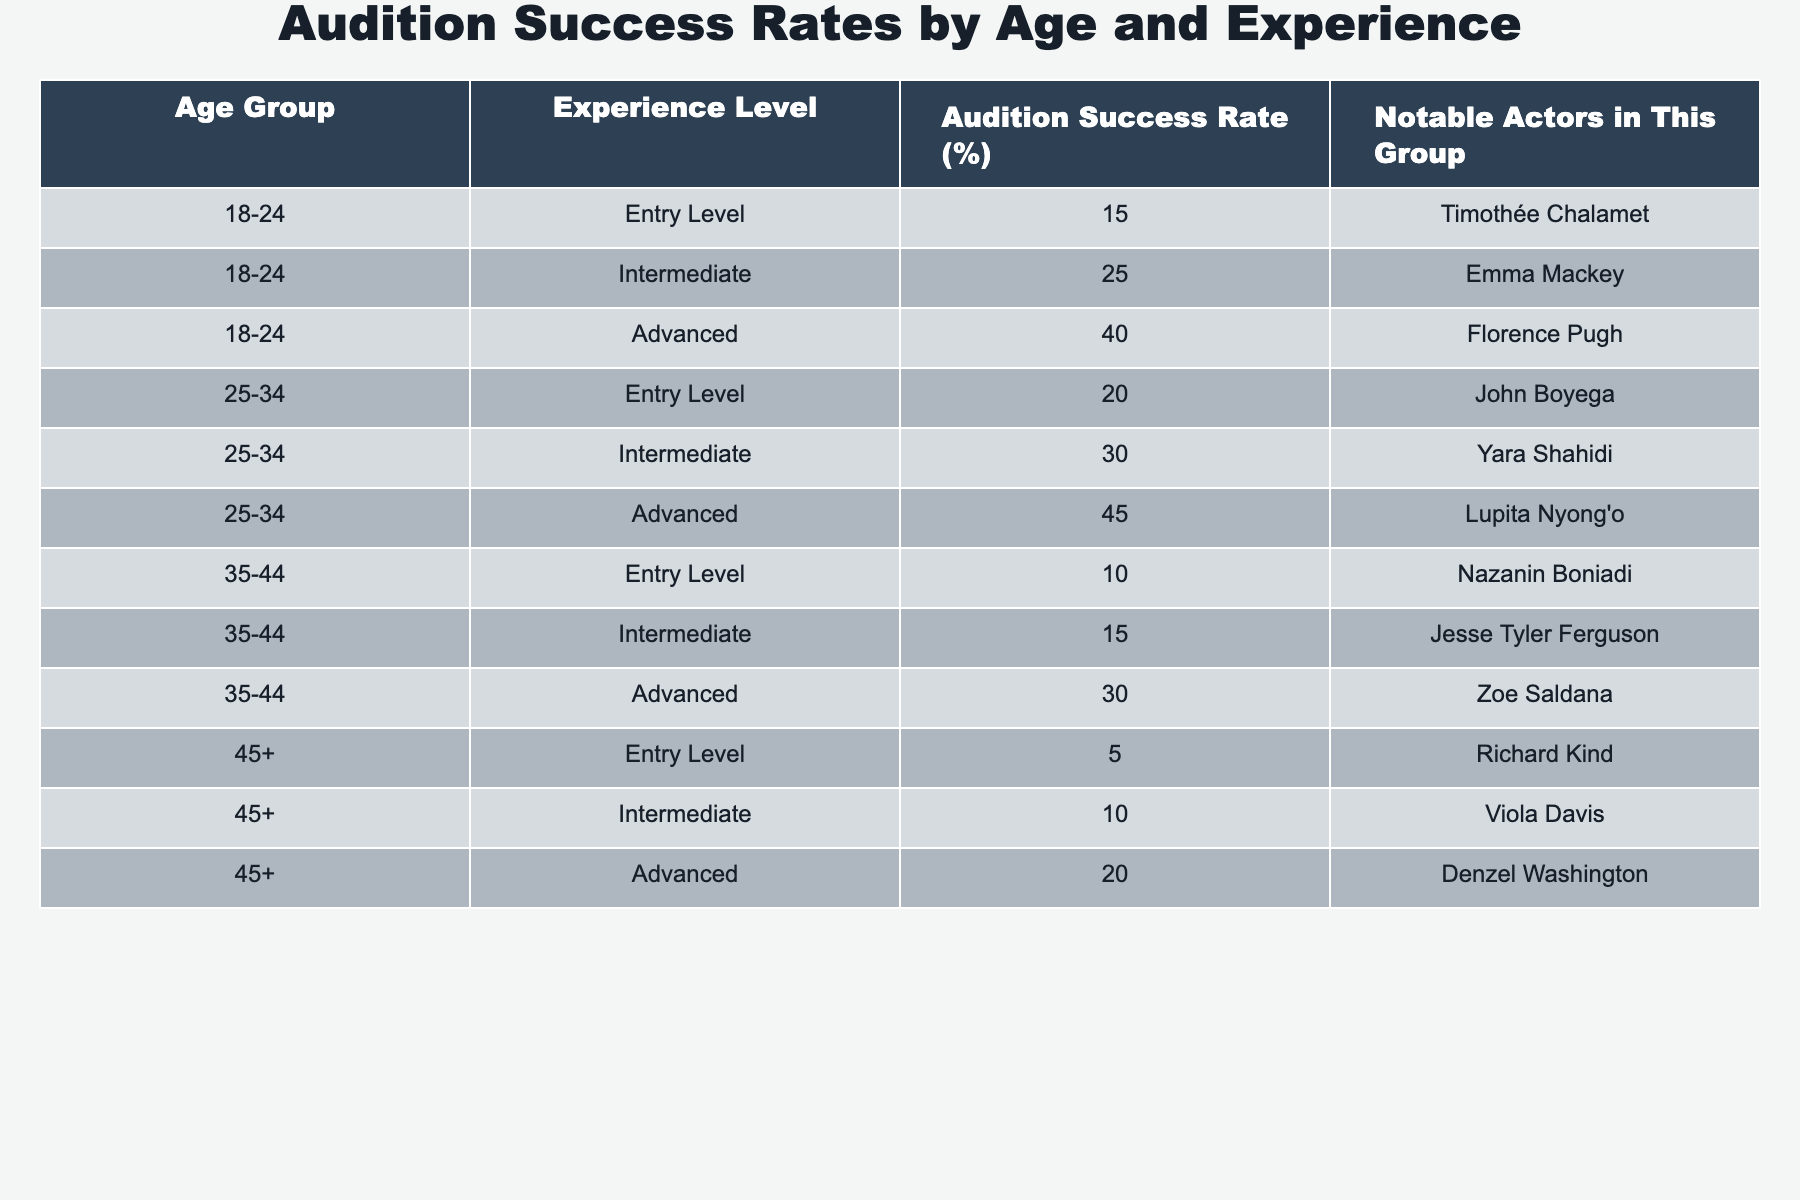What is the audition success rate for actors aged 45 and above at the entry level? From the table, the audition success rate for the "Entry Level" experience among the age group "45+" is listed as 5%.
Answer: 5% Who is the notable actor in the 25-34 age group with the highest success rate? The table shows that the "Advanced" experience level in the 25-34 age group has the highest success rate of 45%, and the notable actor for this group is Lupita Nyong'o.
Answer: Lupita Nyong'o What is the difference in audition success rates between the 18-24 age group advanced level and the 35-44 age group advanced level? The "Advanced" success rate for the 18-24 age group is 40%, while for the 35-44 age group, it's 30%. The difference is 40% - 30% = 10%.
Answer: 10% Are there any age groups where the audition success rate is higher for entry-level actors compared to intermediate-level actors? By comparing the entry-level and intermediate-level success rates from the table, we see that both age groups 25-34 and 18-24 have higher entry-level success rates than intermediate rates. Therefore, the statement is true.
Answer: Yes What is the average audition success rate for intermediate-level actors across all age groups? To find the average, first, we identify the success rates for intermediate actors: 25%, 30%, 15%, and 10%. The average can be calculated as (25 + 30 + 15 + 10) / 4 = 80 / 4 = 20%.
Answer: 20% Which age group has the lowest audition success rate at the advanced level? Looking at the table, the "Advanced" success rate for the 35-44 age group is 30%, which is lower than the other age groups (40% for 18-24 and 45% for 25-34). Thus, the 35-44 age group has the lowest rate at this level.
Answer: 35-44 age group What percentage of "Entry Level" actors aged 35-44 succeed in auditions? The audition success rate for "Entry Level" actors in the 35-44 age group is 10%, as indicated in the table.
Answer: 10% If we combine the success rates for all advanced-level actors, what would the total be? The "Advanced" success rates are 40% (18-24) + 45% (25-34) + 30% (35-44) + 20% (45+) = 135%.
Answer: 135% Is it true that all age groups have at least one notable actor listed in the table? By reviewing the table, every age group has corresponding notable actors listed, confirming that the statement is true.
Answer: Yes Which experience level in the age group of 18-24 has the second-highest success rate? In the 18-24 age group, the "Advanced" level has the highest rate at 40%, followed by "Intermediate" at 25%. Hence, the second-highest is the Intermediate level.
Answer: Intermediate level 